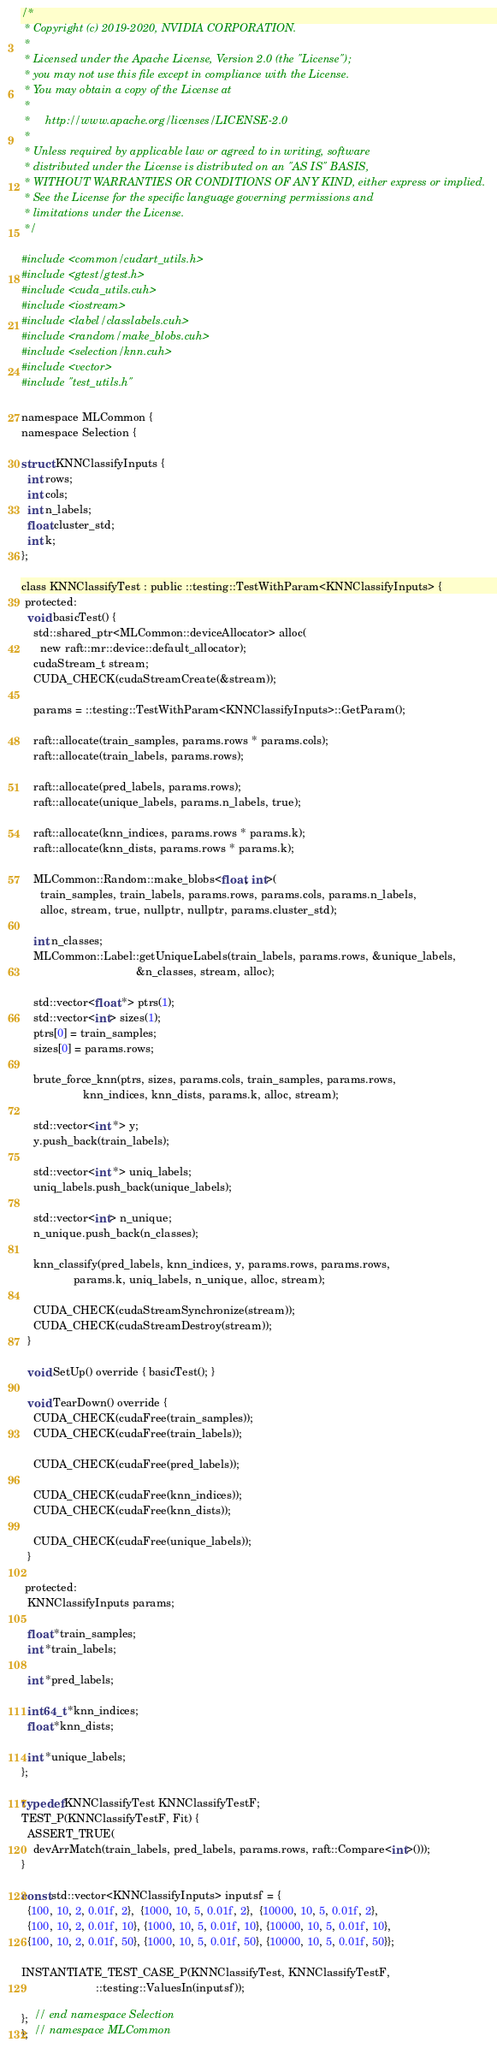<code> <loc_0><loc_0><loc_500><loc_500><_Cuda_>/*
 * Copyright (c) 2019-2020, NVIDIA CORPORATION.
 *
 * Licensed under the Apache License, Version 2.0 (the "License");
 * you may not use this file except in compliance with the License.
 * You may obtain a copy of the License at
 *
 *     http://www.apache.org/licenses/LICENSE-2.0
 *
 * Unless required by applicable law or agreed to in writing, software
 * distributed under the License is distributed on an "AS IS" BASIS,
 * WITHOUT WARRANTIES OR CONDITIONS OF ANY KIND, either express or implied.
 * See the License for the specific language governing permissions and
 * limitations under the License.
 */

#include <common/cudart_utils.h>
#include <gtest/gtest.h>
#include <cuda_utils.cuh>
#include <iostream>
#include <label/classlabels.cuh>
#include <random/make_blobs.cuh>
#include <selection/knn.cuh>
#include <vector>
#include "test_utils.h"

namespace MLCommon {
namespace Selection {

struct KNNClassifyInputs {
  int rows;
  int cols;
  int n_labels;
  float cluster_std;
  int k;
};

class KNNClassifyTest : public ::testing::TestWithParam<KNNClassifyInputs> {
 protected:
  void basicTest() {
    std::shared_ptr<MLCommon::deviceAllocator> alloc(
      new raft::mr::device::default_allocator);
    cudaStream_t stream;
    CUDA_CHECK(cudaStreamCreate(&stream));

    params = ::testing::TestWithParam<KNNClassifyInputs>::GetParam();

    raft::allocate(train_samples, params.rows * params.cols);
    raft::allocate(train_labels, params.rows);

    raft::allocate(pred_labels, params.rows);
    raft::allocate(unique_labels, params.n_labels, true);

    raft::allocate(knn_indices, params.rows * params.k);
    raft::allocate(knn_dists, params.rows * params.k);

    MLCommon::Random::make_blobs<float, int>(
      train_samples, train_labels, params.rows, params.cols, params.n_labels,
      alloc, stream, true, nullptr, nullptr, params.cluster_std);

    int n_classes;
    MLCommon::Label::getUniqueLabels(train_labels, params.rows, &unique_labels,
                                     &n_classes, stream, alloc);

    std::vector<float *> ptrs(1);
    std::vector<int> sizes(1);
    ptrs[0] = train_samples;
    sizes[0] = params.rows;

    brute_force_knn(ptrs, sizes, params.cols, train_samples, params.rows,
                    knn_indices, knn_dists, params.k, alloc, stream);

    std::vector<int *> y;
    y.push_back(train_labels);

    std::vector<int *> uniq_labels;
    uniq_labels.push_back(unique_labels);

    std::vector<int> n_unique;
    n_unique.push_back(n_classes);

    knn_classify(pred_labels, knn_indices, y, params.rows, params.rows,
                 params.k, uniq_labels, n_unique, alloc, stream);

    CUDA_CHECK(cudaStreamSynchronize(stream));
    CUDA_CHECK(cudaStreamDestroy(stream));
  }

  void SetUp() override { basicTest(); }

  void TearDown() override {
    CUDA_CHECK(cudaFree(train_samples));
    CUDA_CHECK(cudaFree(train_labels));

    CUDA_CHECK(cudaFree(pred_labels));

    CUDA_CHECK(cudaFree(knn_indices));
    CUDA_CHECK(cudaFree(knn_dists));

    CUDA_CHECK(cudaFree(unique_labels));
  }

 protected:
  KNNClassifyInputs params;

  float *train_samples;
  int *train_labels;

  int *pred_labels;

  int64_t *knn_indices;
  float *knn_dists;

  int *unique_labels;
};

typedef KNNClassifyTest KNNClassifyTestF;
TEST_P(KNNClassifyTestF, Fit) {
  ASSERT_TRUE(
    devArrMatch(train_labels, pred_labels, params.rows, raft::Compare<int>()));
}

const std::vector<KNNClassifyInputs> inputsf = {
  {100, 10, 2, 0.01f, 2},  {1000, 10, 5, 0.01f, 2},  {10000, 10, 5, 0.01f, 2},
  {100, 10, 2, 0.01f, 10}, {1000, 10, 5, 0.01f, 10}, {10000, 10, 5, 0.01f, 10},
  {100, 10, 2, 0.01f, 50}, {1000, 10, 5, 0.01f, 50}, {10000, 10, 5, 0.01f, 50}};

INSTANTIATE_TEST_CASE_P(KNNClassifyTest, KNNClassifyTestF,
                        ::testing::ValuesIn(inputsf));

};  // end namespace Selection
};  // namespace MLCommon
</code> 